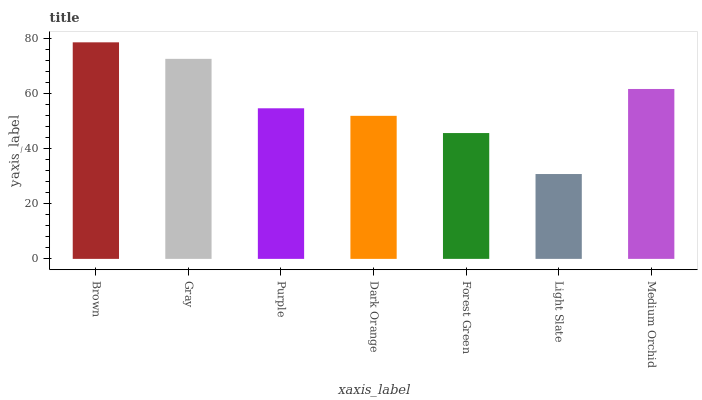Is Light Slate the minimum?
Answer yes or no. Yes. Is Brown the maximum?
Answer yes or no. Yes. Is Gray the minimum?
Answer yes or no. No. Is Gray the maximum?
Answer yes or no. No. Is Brown greater than Gray?
Answer yes or no. Yes. Is Gray less than Brown?
Answer yes or no. Yes. Is Gray greater than Brown?
Answer yes or no. No. Is Brown less than Gray?
Answer yes or no. No. Is Purple the high median?
Answer yes or no. Yes. Is Purple the low median?
Answer yes or no. Yes. Is Medium Orchid the high median?
Answer yes or no. No. Is Dark Orange the low median?
Answer yes or no. No. 